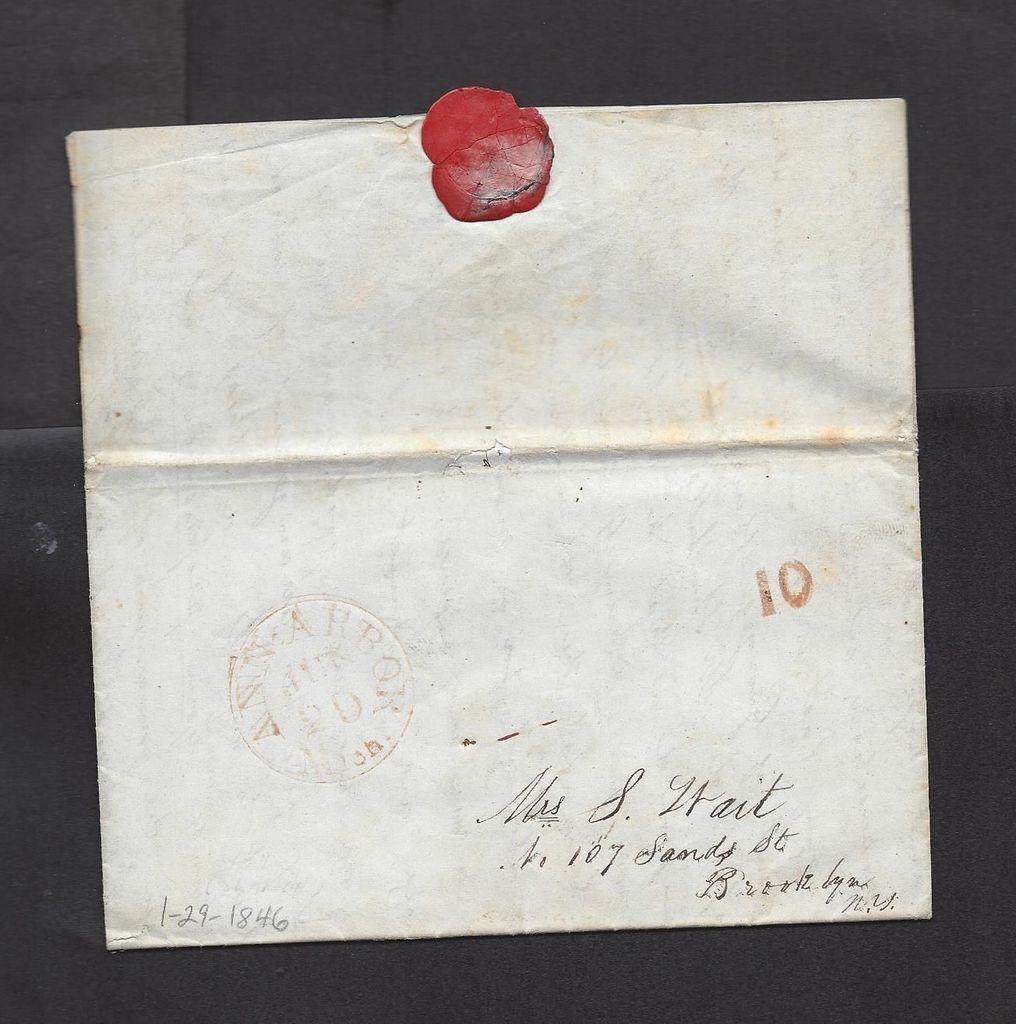What date is mentioned on the left corner of the envelope?
Provide a short and direct response. 1-29-1846. What number is stamped in red ink?
Offer a very short reply. 10. 